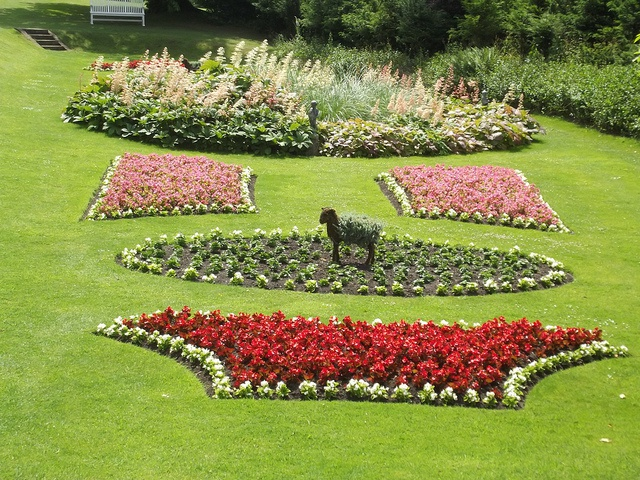Describe the objects in this image and their specific colors. I can see sheep in khaki, black, darkgreen, gray, and olive tones and bench in khaki, darkgray, gray, and black tones in this image. 